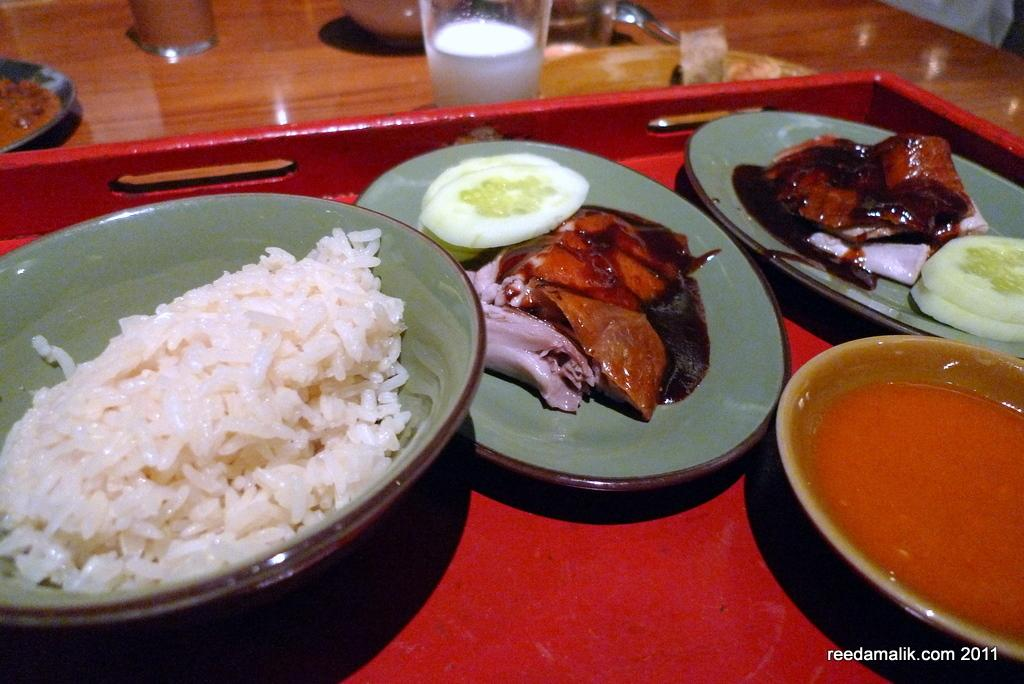What types of containers are visible in the image? There are bowls, plates, and glasses in the image. What else is present on the wooden platform? There is a tray in the image. What is the primary purpose of the objects on the wooden platform? The objects are used for serving food, as there is food in the image. What is the material of the platform on which the objects are placed? The objects are on a wooden platform. What type of acoustics can be heard from the clam in the image? There is no clam present in the image, and therefore no acoustics can be heard from it. 